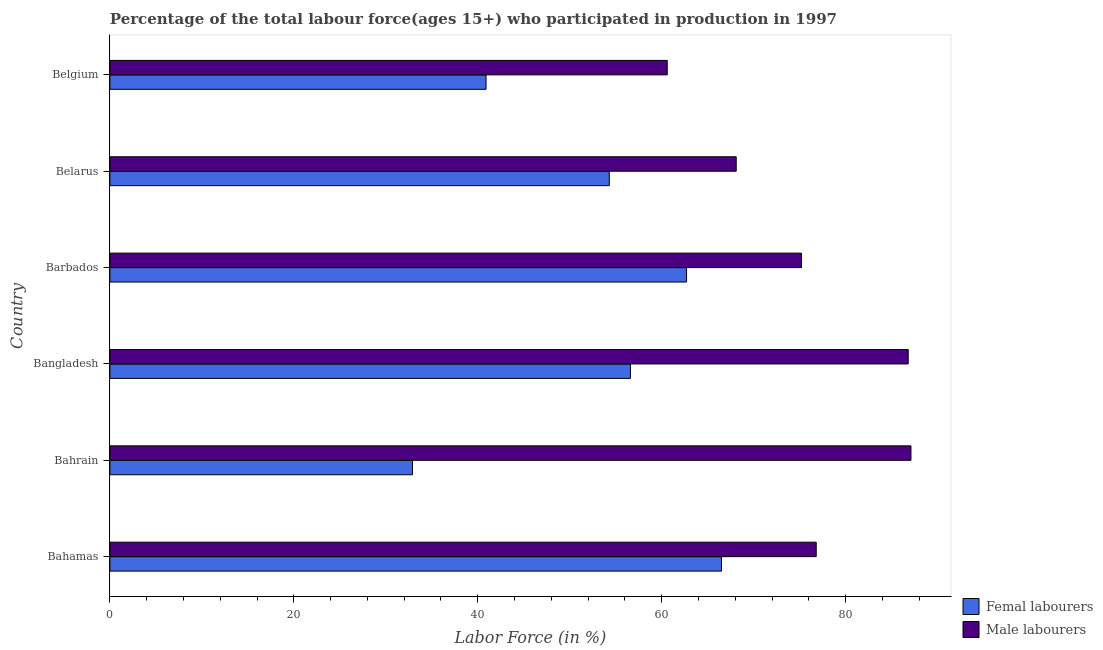How many different coloured bars are there?
Ensure brevity in your answer.  2. How many groups of bars are there?
Your answer should be compact. 6. Are the number of bars on each tick of the Y-axis equal?
Your answer should be compact. Yes. How many bars are there on the 5th tick from the top?
Your response must be concise. 2. How many bars are there on the 2nd tick from the bottom?
Offer a terse response. 2. What is the label of the 1st group of bars from the top?
Your answer should be very brief. Belgium. In how many cases, is the number of bars for a given country not equal to the number of legend labels?
Your answer should be very brief. 0. What is the percentage of female labor force in Barbados?
Offer a very short reply. 62.7. Across all countries, what is the maximum percentage of female labor force?
Provide a short and direct response. 66.5. Across all countries, what is the minimum percentage of female labor force?
Ensure brevity in your answer.  32.9. In which country was the percentage of female labor force maximum?
Keep it short and to the point. Bahamas. In which country was the percentage of male labour force minimum?
Offer a very short reply. Belgium. What is the total percentage of female labor force in the graph?
Your answer should be compact. 313.9. What is the difference between the percentage of female labor force in Bangladesh and the percentage of male labour force in Bahamas?
Your response must be concise. -20.2. What is the average percentage of male labour force per country?
Provide a succinct answer. 75.77. What is the difference between the percentage of male labour force and percentage of female labor force in Bahrain?
Offer a terse response. 54.2. What is the ratio of the percentage of female labor force in Bahrain to that in Bangladesh?
Your answer should be very brief. 0.58. Is the percentage of male labour force in Bahamas less than that in Bangladesh?
Keep it short and to the point. Yes. Is the difference between the percentage of female labor force in Bahamas and Barbados greater than the difference between the percentage of male labour force in Bahamas and Barbados?
Keep it short and to the point. Yes. What is the difference between the highest and the second highest percentage of male labour force?
Your response must be concise. 0.3. What is the difference between the highest and the lowest percentage of male labour force?
Offer a very short reply. 26.5. In how many countries, is the percentage of female labor force greater than the average percentage of female labor force taken over all countries?
Offer a very short reply. 4. What does the 1st bar from the top in Bangladesh represents?
Provide a short and direct response. Male labourers. What does the 2nd bar from the bottom in Belgium represents?
Your response must be concise. Male labourers. How many bars are there?
Give a very brief answer. 12. Does the graph contain grids?
Your answer should be very brief. No. Where does the legend appear in the graph?
Offer a very short reply. Bottom right. What is the title of the graph?
Your answer should be compact. Percentage of the total labour force(ages 15+) who participated in production in 1997. Does "Urban" appear as one of the legend labels in the graph?
Keep it short and to the point. No. What is the label or title of the X-axis?
Give a very brief answer. Labor Force (in %). What is the Labor Force (in %) of Femal labourers in Bahamas?
Provide a succinct answer. 66.5. What is the Labor Force (in %) of Male labourers in Bahamas?
Offer a terse response. 76.8. What is the Labor Force (in %) of Femal labourers in Bahrain?
Ensure brevity in your answer.  32.9. What is the Labor Force (in %) of Male labourers in Bahrain?
Keep it short and to the point. 87.1. What is the Labor Force (in %) of Femal labourers in Bangladesh?
Your response must be concise. 56.6. What is the Labor Force (in %) in Male labourers in Bangladesh?
Your response must be concise. 86.8. What is the Labor Force (in %) in Femal labourers in Barbados?
Your answer should be compact. 62.7. What is the Labor Force (in %) of Male labourers in Barbados?
Your answer should be compact. 75.2. What is the Labor Force (in %) of Femal labourers in Belarus?
Your answer should be compact. 54.3. What is the Labor Force (in %) of Male labourers in Belarus?
Provide a short and direct response. 68.1. What is the Labor Force (in %) in Femal labourers in Belgium?
Offer a very short reply. 40.9. What is the Labor Force (in %) of Male labourers in Belgium?
Make the answer very short. 60.6. Across all countries, what is the maximum Labor Force (in %) in Femal labourers?
Make the answer very short. 66.5. Across all countries, what is the maximum Labor Force (in %) of Male labourers?
Offer a very short reply. 87.1. Across all countries, what is the minimum Labor Force (in %) in Femal labourers?
Make the answer very short. 32.9. Across all countries, what is the minimum Labor Force (in %) of Male labourers?
Ensure brevity in your answer.  60.6. What is the total Labor Force (in %) of Femal labourers in the graph?
Offer a terse response. 313.9. What is the total Labor Force (in %) of Male labourers in the graph?
Provide a short and direct response. 454.6. What is the difference between the Labor Force (in %) in Femal labourers in Bahamas and that in Bahrain?
Make the answer very short. 33.6. What is the difference between the Labor Force (in %) in Male labourers in Bahamas and that in Barbados?
Offer a very short reply. 1.6. What is the difference between the Labor Force (in %) of Male labourers in Bahamas and that in Belarus?
Offer a terse response. 8.7. What is the difference between the Labor Force (in %) of Femal labourers in Bahamas and that in Belgium?
Offer a very short reply. 25.6. What is the difference between the Labor Force (in %) in Male labourers in Bahamas and that in Belgium?
Your answer should be compact. 16.2. What is the difference between the Labor Force (in %) of Femal labourers in Bahrain and that in Bangladesh?
Keep it short and to the point. -23.7. What is the difference between the Labor Force (in %) in Femal labourers in Bahrain and that in Barbados?
Offer a very short reply. -29.8. What is the difference between the Labor Force (in %) in Male labourers in Bahrain and that in Barbados?
Your response must be concise. 11.9. What is the difference between the Labor Force (in %) of Femal labourers in Bahrain and that in Belarus?
Your response must be concise. -21.4. What is the difference between the Labor Force (in %) in Femal labourers in Bahrain and that in Belgium?
Offer a very short reply. -8. What is the difference between the Labor Force (in %) in Femal labourers in Bangladesh and that in Barbados?
Keep it short and to the point. -6.1. What is the difference between the Labor Force (in %) in Femal labourers in Bangladesh and that in Belarus?
Provide a short and direct response. 2.3. What is the difference between the Labor Force (in %) of Femal labourers in Bangladesh and that in Belgium?
Your response must be concise. 15.7. What is the difference between the Labor Force (in %) in Male labourers in Bangladesh and that in Belgium?
Your answer should be compact. 26.2. What is the difference between the Labor Force (in %) of Femal labourers in Barbados and that in Belarus?
Make the answer very short. 8.4. What is the difference between the Labor Force (in %) of Femal labourers in Barbados and that in Belgium?
Provide a succinct answer. 21.8. What is the difference between the Labor Force (in %) of Male labourers in Barbados and that in Belgium?
Your answer should be very brief. 14.6. What is the difference between the Labor Force (in %) in Femal labourers in Belarus and that in Belgium?
Your response must be concise. 13.4. What is the difference between the Labor Force (in %) of Femal labourers in Bahamas and the Labor Force (in %) of Male labourers in Bahrain?
Your response must be concise. -20.6. What is the difference between the Labor Force (in %) in Femal labourers in Bahamas and the Labor Force (in %) in Male labourers in Bangladesh?
Your answer should be compact. -20.3. What is the difference between the Labor Force (in %) in Femal labourers in Bahamas and the Labor Force (in %) in Male labourers in Barbados?
Make the answer very short. -8.7. What is the difference between the Labor Force (in %) in Femal labourers in Bahamas and the Labor Force (in %) in Male labourers in Belarus?
Keep it short and to the point. -1.6. What is the difference between the Labor Force (in %) in Femal labourers in Bahrain and the Labor Force (in %) in Male labourers in Bangladesh?
Ensure brevity in your answer.  -53.9. What is the difference between the Labor Force (in %) in Femal labourers in Bahrain and the Labor Force (in %) in Male labourers in Barbados?
Give a very brief answer. -42.3. What is the difference between the Labor Force (in %) in Femal labourers in Bahrain and the Labor Force (in %) in Male labourers in Belarus?
Provide a short and direct response. -35.2. What is the difference between the Labor Force (in %) of Femal labourers in Bahrain and the Labor Force (in %) of Male labourers in Belgium?
Ensure brevity in your answer.  -27.7. What is the difference between the Labor Force (in %) of Femal labourers in Bangladesh and the Labor Force (in %) of Male labourers in Barbados?
Give a very brief answer. -18.6. What is the difference between the Labor Force (in %) of Femal labourers in Bangladesh and the Labor Force (in %) of Male labourers in Belarus?
Provide a succinct answer. -11.5. What is the difference between the Labor Force (in %) of Femal labourers in Bangladesh and the Labor Force (in %) of Male labourers in Belgium?
Provide a short and direct response. -4. What is the difference between the Labor Force (in %) of Femal labourers in Barbados and the Labor Force (in %) of Male labourers in Belgium?
Offer a very short reply. 2.1. What is the difference between the Labor Force (in %) of Femal labourers in Belarus and the Labor Force (in %) of Male labourers in Belgium?
Ensure brevity in your answer.  -6.3. What is the average Labor Force (in %) in Femal labourers per country?
Ensure brevity in your answer.  52.32. What is the average Labor Force (in %) of Male labourers per country?
Your answer should be very brief. 75.77. What is the difference between the Labor Force (in %) in Femal labourers and Labor Force (in %) in Male labourers in Bahamas?
Keep it short and to the point. -10.3. What is the difference between the Labor Force (in %) in Femal labourers and Labor Force (in %) in Male labourers in Bahrain?
Make the answer very short. -54.2. What is the difference between the Labor Force (in %) in Femal labourers and Labor Force (in %) in Male labourers in Bangladesh?
Your answer should be compact. -30.2. What is the difference between the Labor Force (in %) in Femal labourers and Labor Force (in %) in Male labourers in Belgium?
Your answer should be compact. -19.7. What is the ratio of the Labor Force (in %) in Femal labourers in Bahamas to that in Bahrain?
Give a very brief answer. 2.02. What is the ratio of the Labor Force (in %) in Male labourers in Bahamas to that in Bahrain?
Keep it short and to the point. 0.88. What is the ratio of the Labor Force (in %) of Femal labourers in Bahamas to that in Bangladesh?
Give a very brief answer. 1.17. What is the ratio of the Labor Force (in %) of Male labourers in Bahamas to that in Bangladesh?
Offer a very short reply. 0.88. What is the ratio of the Labor Force (in %) in Femal labourers in Bahamas to that in Barbados?
Make the answer very short. 1.06. What is the ratio of the Labor Force (in %) in Male labourers in Bahamas to that in Barbados?
Provide a succinct answer. 1.02. What is the ratio of the Labor Force (in %) of Femal labourers in Bahamas to that in Belarus?
Keep it short and to the point. 1.22. What is the ratio of the Labor Force (in %) in Male labourers in Bahamas to that in Belarus?
Ensure brevity in your answer.  1.13. What is the ratio of the Labor Force (in %) in Femal labourers in Bahamas to that in Belgium?
Give a very brief answer. 1.63. What is the ratio of the Labor Force (in %) in Male labourers in Bahamas to that in Belgium?
Provide a succinct answer. 1.27. What is the ratio of the Labor Force (in %) in Femal labourers in Bahrain to that in Bangladesh?
Make the answer very short. 0.58. What is the ratio of the Labor Force (in %) in Male labourers in Bahrain to that in Bangladesh?
Keep it short and to the point. 1. What is the ratio of the Labor Force (in %) in Femal labourers in Bahrain to that in Barbados?
Your response must be concise. 0.52. What is the ratio of the Labor Force (in %) of Male labourers in Bahrain to that in Barbados?
Provide a succinct answer. 1.16. What is the ratio of the Labor Force (in %) of Femal labourers in Bahrain to that in Belarus?
Give a very brief answer. 0.61. What is the ratio of the Labor Force (in %) in Male labourers in Bahrain to that in Belarus?
Your answer should be compact. 1.28. What is the ratio of the Labor Force (in %) in Femal labourers in Bahrain to that in Belgium?
Make the answer very short. 0.8. What is the ratio of the Labor Force (in %) in Male labourers in Bahrain to that in Belgium?
Offer a very short reply. 1.44. What is the ratio of the Labor Force (in %) in Femal labourers in Bangladesh to that in Barbados?
Your answer should be compact. 0.9. What is the ratio of the Labor Force (in %) of Male labourers in Bangladesh to that in Barbados?
Provide a short and direct response. 1.15. What is the ratio of the Labor Force (in %) of Femal labourers in Bangladesh to that in Belarus?
Ensure brevity in your answer.  1.04. What is the ratio of the Labor Force (in %) in Male labourers in Bangladesh to that in Belarus?
Offer a very short reply. 1.27. What is the ratio of the Labor Force (in %) in Femal labourers in Bangladesh to that in Belgium?
Offer a very short reply. 1.38. What is the ratio of the Labor Force (in %) of Male labourers in Bangladesh to that in Belgium?
Make the answer very short. 1.43. What is the ratio of the Labor Force (in %) of Femal labourers in Barbados to that in Belarus?
Make the answer very short. 1.15. What is the ratio of the Labor Force (in %) of Male labourers in Barbados to that in Belarus?
Provide a succinct answer. 1.1. What is the ratio of the Labor Force (in %) in Femal labourers in Barbados to that in Belgium?
Provide a short and direct response. 1.53. What is the ratio of the Labor Force (in %) in Male labourers in Barbados to that in Belgium?
Give a very brief answer. 1.24. What is the ratio of the Labor Force (in %) in Femal labourers in Belarus to that in Belgium?
Give a very brief answer. 1.33. What is the ratio of the Labor Force (in %) of Male labourers in Belarus to that in Belgium?
Offer a very short reply. 1.12. What is the difference between the highest and the second highest Labor Force (in %) in Femal labourers?
Offer a terse response. 3.8. What is the difference between the highest and the lowest Labor Force (in %) in Femal labourers?
Your response must be concise. 33.6. 